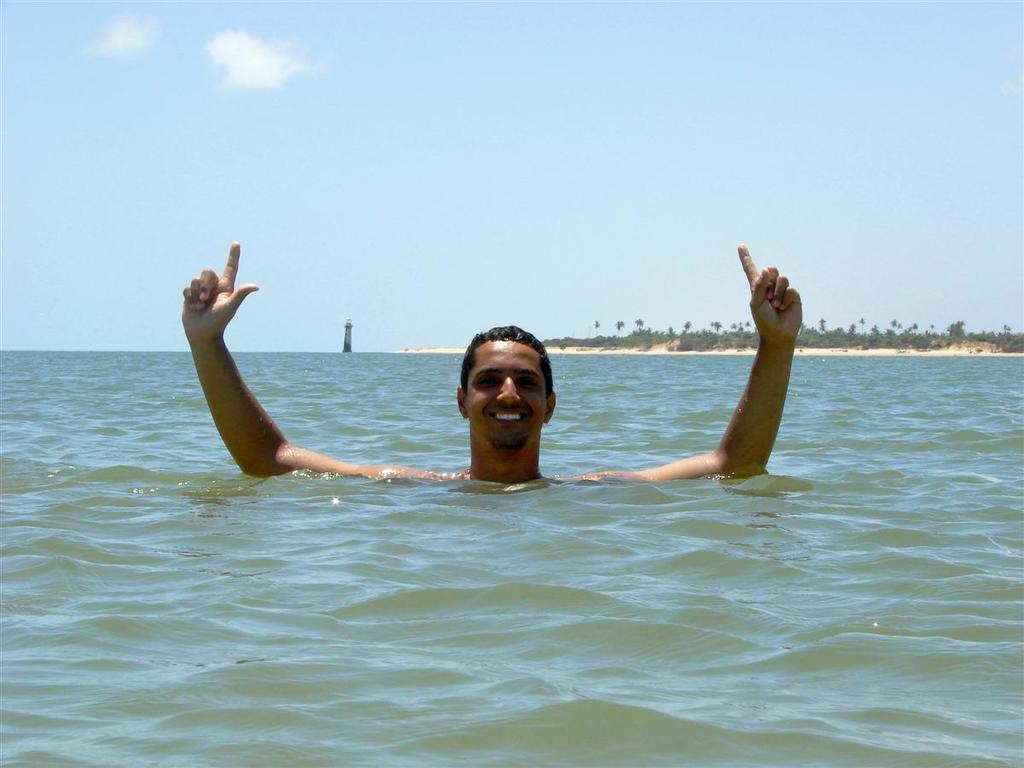What is the person in the image doing? The person is swimming in the water. Is the person doing anything else besides swimming? Yes, the person is posing for a photo. What can be seen in the background of the image? There are many plants on the sand surface in the background. What type of weather can be seen in the image? The provided facts do not mention the weather, so it cannot be determined from the image. 